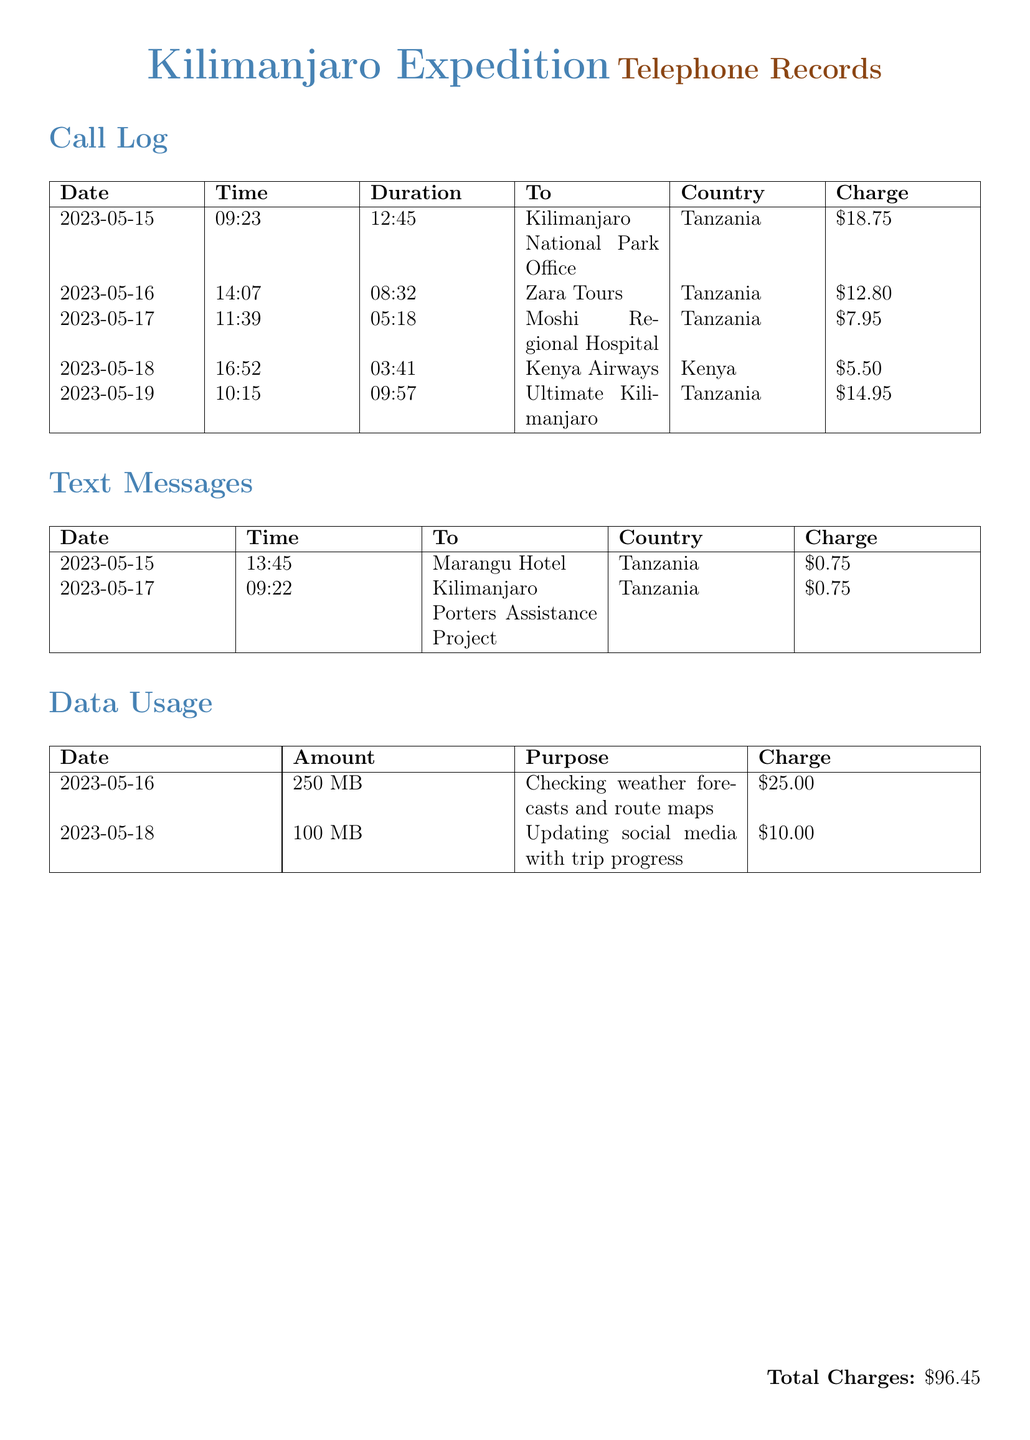What is the total charge incurred? The total charge incurred is found at the bottom of the document, which sums up all charges from calls, texts, and data usage.
Answer: $96.45 Which organization was contacted on May 17? The organization contacted on May 17 can be found in the call log where the call made at 11:39 is listed.
Answer: Moshi Regional Hospital How much was spent on data usage for checking weather forecasts? The amount spent on data for checking weather forecasts is listed in the data usage section specifically for May 16.
Answer: $25.00 What was the duration of the call made to Kilimanjaro National Park Office? The duration of the call to Kilimanjaro National Park Office is provided in the call log for May 15.
Answer: 12:45 How many text messages were sent according to the document? The document lists text messages in a specific section, totaling two entries.
Answer: 2 What was the charge for the call to Kenya Airways? The charge for the call made to Kenya Airways is listed in the call log under the date May 18.
Answer: $5.50 Which country had the highest charge for a call? To find the highest charge for a call, one must review the call log and identify the maximum charge amount.
Answer: Tanzania What was the charge incurred for updating social media? The document details a specific amount charged for the purpose of updating social media in the data usage section.
Answer: $10.00 